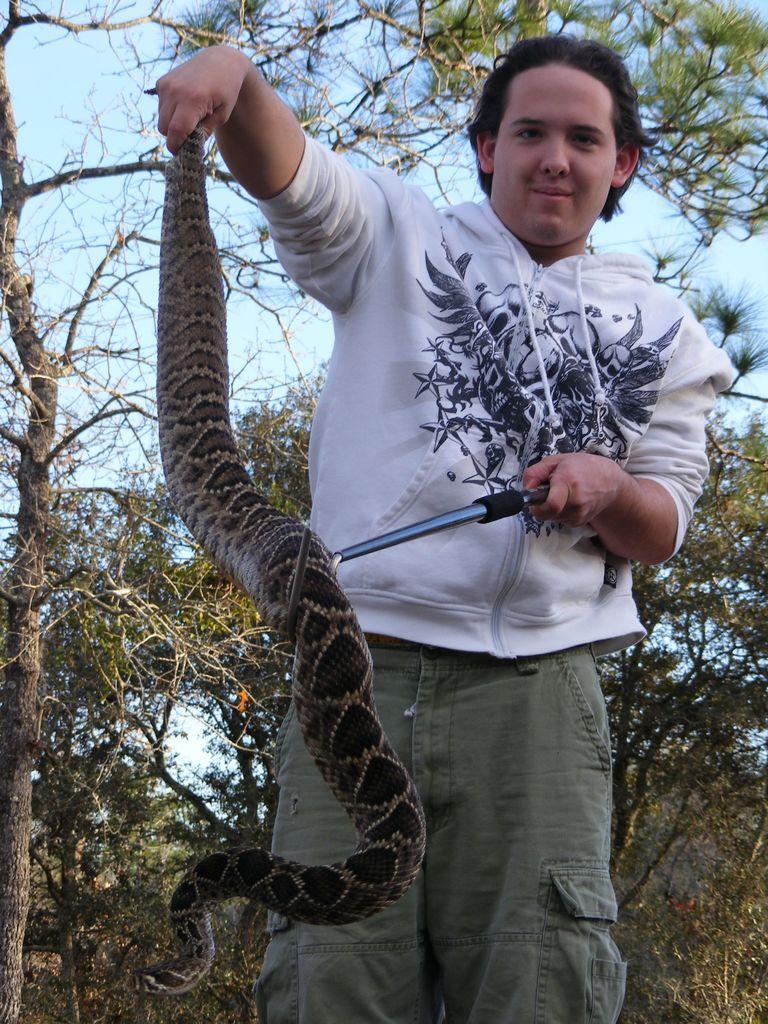Please provide a concise description of this image. In this picture there is a boy who is standing on the right side of the image, by holding a snake in his hands, there are trees in the background area of the image. 